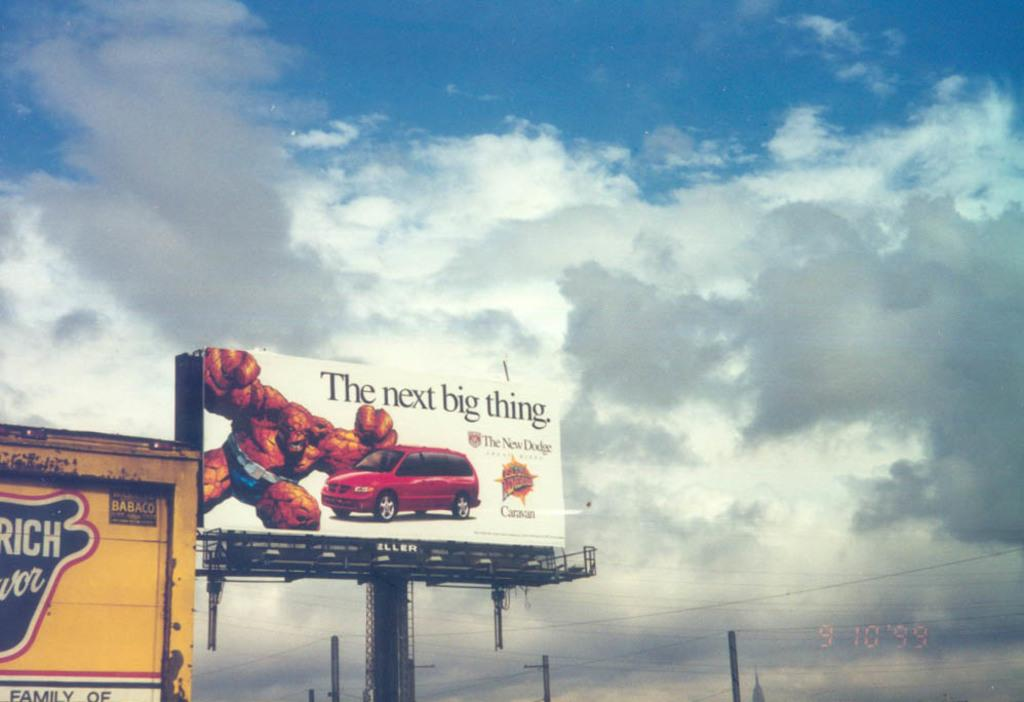Provide a one-sentence caption for the provided image. Billboard beside a building that says the next big thing. 